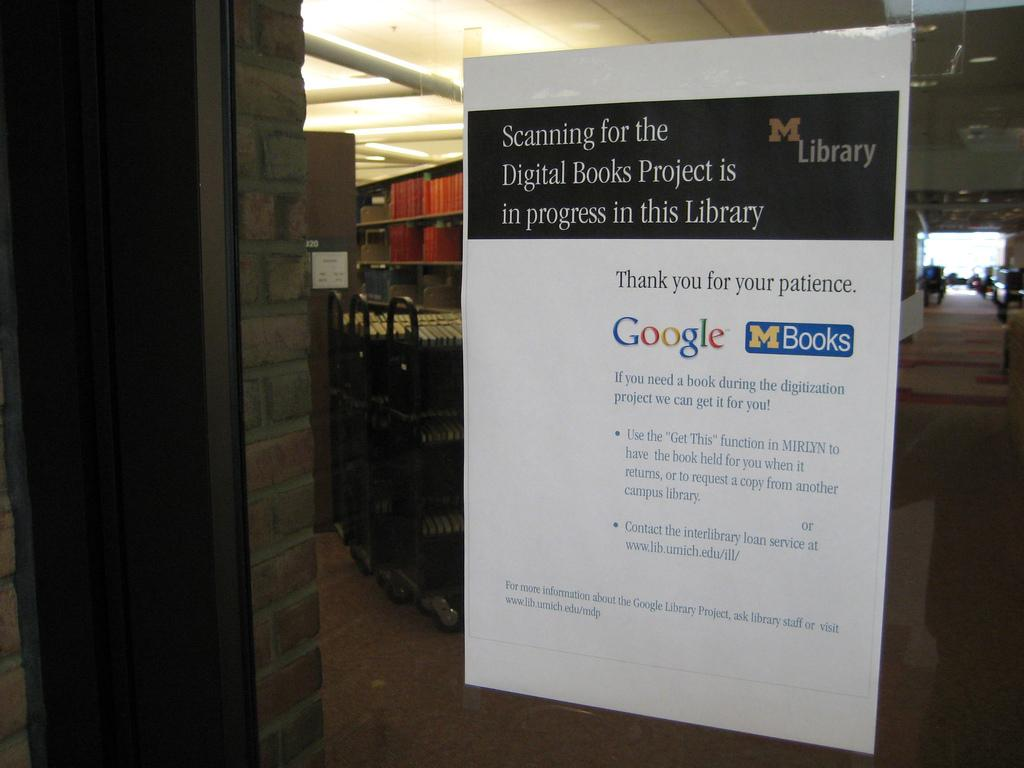<image>
Share a concise interpretation of the image provided. sign on glass door advising people that the library is scanning for the digital books project is in progress 